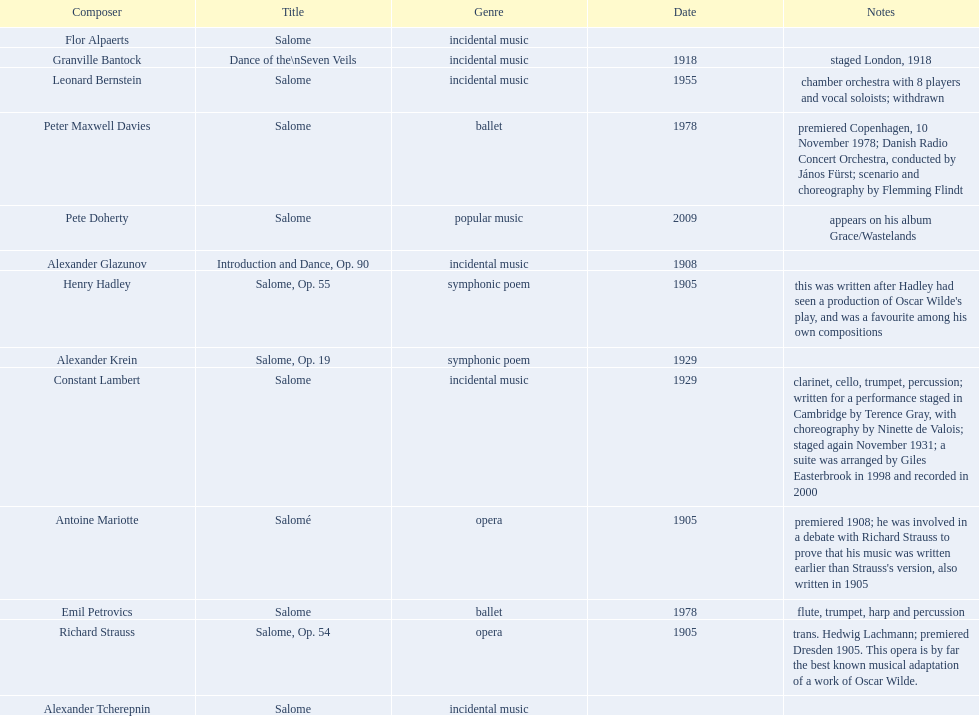Which composer produced his title after 2001? Pete Doherty. 